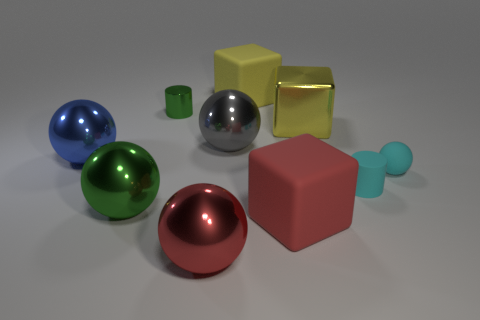Does the big rubber object behind the small ball have the same shape as the red rubber object?
Give a very brief answer. Yes. What color is the big rubber object behind the big green ball?
Your answer should be very brief. Yellow. The small green object that is the same material as the big red sphere is what shape?
Provide a short and direct response. Cylinder. Is there any other thing of the same color as the metal cube?
Provide a succinct answer. Yes. Are there more big objects that are in front of the small green cylinder than large shiny cubes left of the big yellow matte object?
Your response must be concise. Yes. How many green balls have the same size as the green cylinder?
Your answer should be very brief. 0. Are there fewer large red blocks behind the big blue sphere than shiny blocks behind the gray metallic ball?
Provide a short and direct response. Yes. Is there a cyan rubber thing that has the same shape as the large green metal object?
Your answer should be very brief. Yes. Does the big yellow shiny thing have the same shape as the tiny green metal thing?
Make the answer very short. No. How many small objects are either red metal spheres or green matte objects?
Give a very brief answer. 0. 